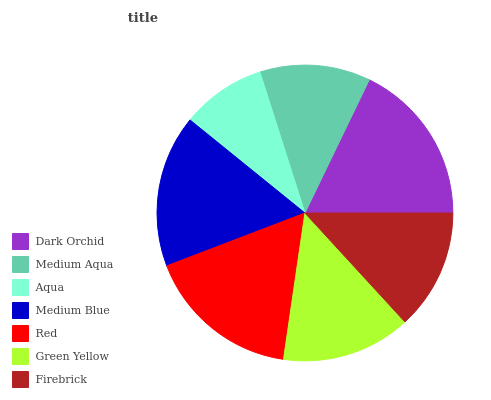Is Aqua the minimum?
Answer yes or no. Yes. Is Dark Orchid the maximum?
Answer yes or no. Yes. Is Medium Aqua the minimum?
Answer yes or no. No. Is Medium Aqua the maximum?
Answer yes or no. No. Is Dark Orchid greater than Medium Aqua?
Answer yes or no. Yes. Is Medium Aqua less than Dark Orchid?
Answer yes or no. Yes. Is Medium Aqua greater than Dark Orchid?
Answer yes or no. No. Is Dark Orchid less than Medium Aqua?
Answer yes or no. No. Is Green Yellow the high median?
Answer yes or no. Yes. Is Green Yellow the low median?
Answer yes or no. Yes. Is Dark Orchid the high median?
Answer yes or no. No. Is Medium Aqua the low median?
Answer yes or no. No. 